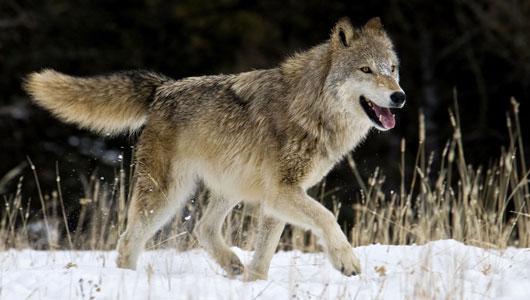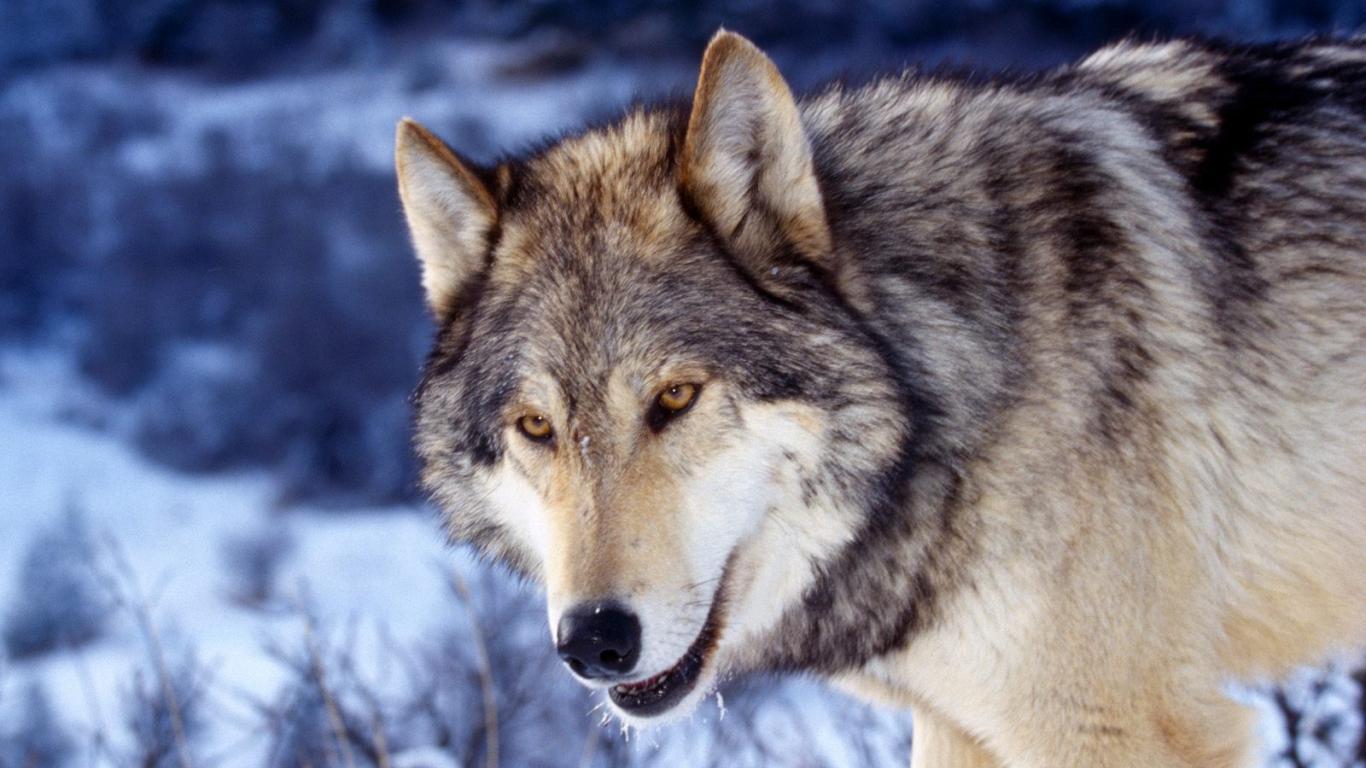The first image is the image on the left, the second image is the image on the right. Given the left and right images, does the statement "At least one wolfe has their body positioned toward the right." hold true? Answer yes or no. Yes. 